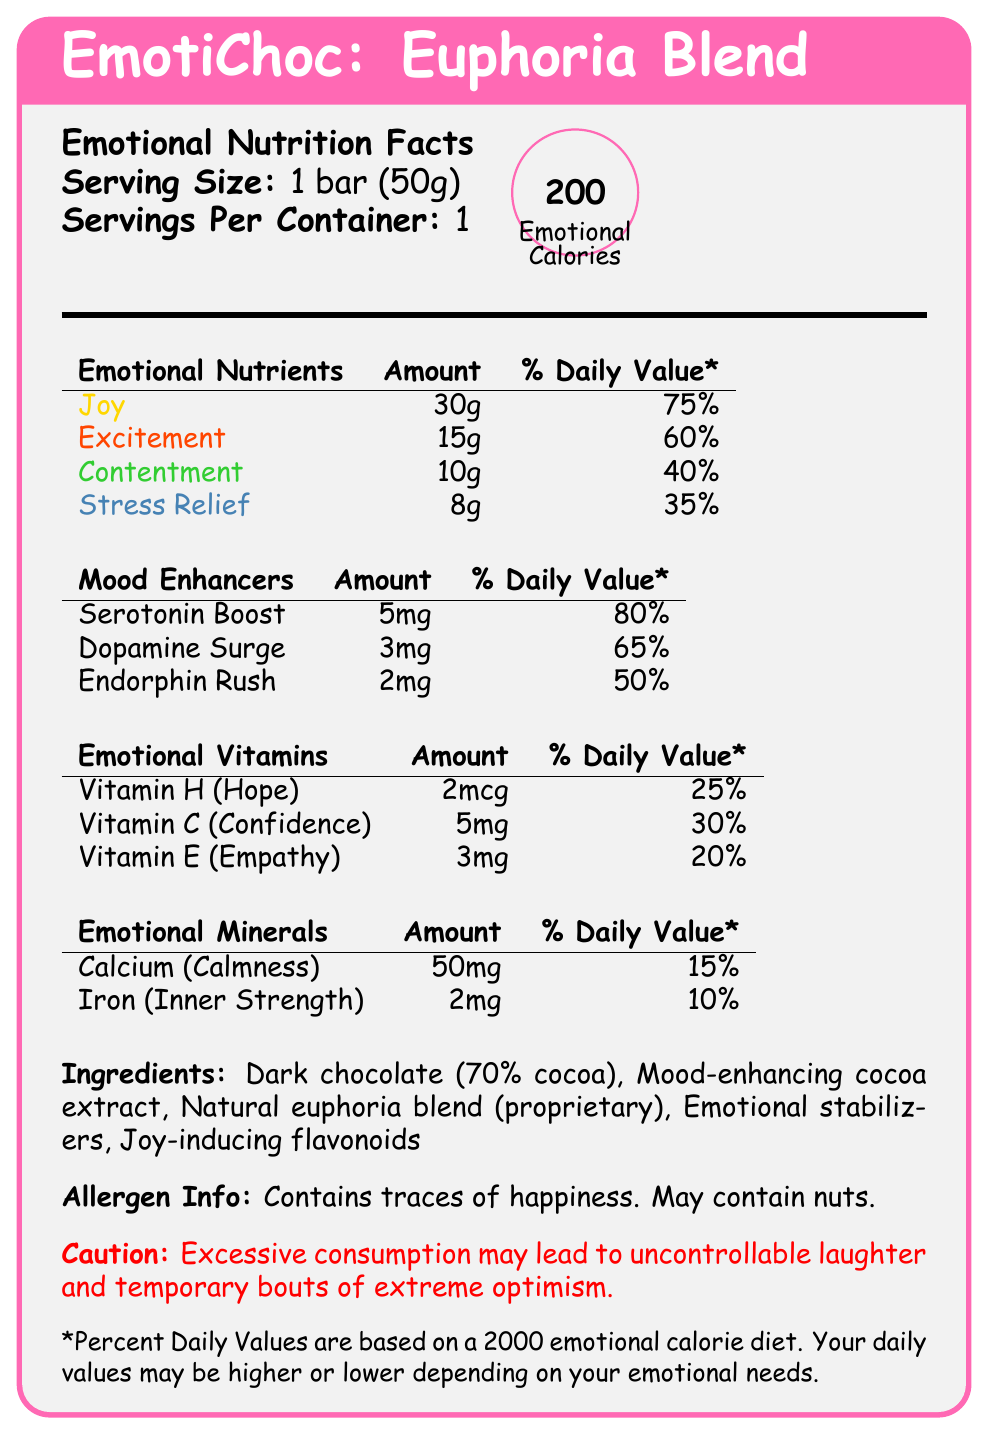What is the serving size for EmotiChoc: Euphoria Blend? The document mentions that the serving size is "1 bar (50g)".
Answer: 1 bar (50g) How many servings are there per container of the EmotiChoc: Euphoria Blend bar? The document states that there is 1 serving per container.
Answer: 1 How many emotional calories are in one serving of EmotiChoc: Euphoria Blend? The document specifies that each serving contains 200 emotional calories.
Answer: 200 What is the percentage of daily value for Joy in one bar of EmotiChoc: Euphoria Blend? The document lists Joy as having 30g, which is 75% of the daily value.
Answer: 75% Which emotional nutrient is the least present in the EmotiChoc: Euphoria Blend bar? The document states that Stress Relief has 8g, which is the least among the emotional nutrients listed.
Answer: Stress Relief Which mood enhancer has the highest daily value percentage in the EmotiChoc: Euphoria Blend bar? A. Serotonin Boost B. Dopamine Surge C. Endorphin Rush The document shows Serotonin Boost with an 80% daily value, which is higher than Dopamine Surge (65%) and Endorphin Rush (50%).
Answer: A. Serotonin Boost What amount of Vitamin H (Hope) does one bar of EmotiChoc: Euphoria Blend contain? The document includes Vitamin H (Hope) as 2mcg in one bar.
Answer: 2mcg Which of the following is not listed as an ingredient in EmotiChoc: Euphoria Blend? A. Dark chocolate B. Joy-inducing flavonoids C. Mood-balancing herbal extract D. Natural euphoria blend The ingredients listed include Dark chocolate, Joy-inducing flavonoids, and Natural euphoria blend but not Mood-balancing herbal extract.
Answer: C. Mood-balancing herbal extract Does the EmotiChoc: Euphoria Blend contain any allergen information? The document states that it contains traces of happiness and may contain nuts.
Answer: Yes What does the caution note in the EmotiChoc: Euphoria Blend mention? The caution warning in the document states these potential effects of consuming too much of the product.
Answer: Excessive consumption may lead to uncontrollable laughter and temporary bouts of extreme optimism. Summarize the main idea of the EmotiChoc: Euphoria Blend document. The document outlines the emotional benefits and nutritional information of EmotiChoc: Euphoria Blend, a chocolate bar designed to alter moods through specific emotional nutrients and mood enhancers, highlighting ingredients, daily values, and precautionary details.
Answer: EmotiChoc: Euphoria Blend is a mood-altering chocolate bar that provides various emotional nutrients, vitamins, and mood enhancers with detailed emotional nutritional information. It includes specific amounts and daily values of components like Joy, Excitement, and Serotonin Boost. The product is made from ingredients that promote mood enhancement and includes a caution about potential side effects from excessive consumption. What is the daily value percentage of Iron (Inner Strength) in one bar of the product? The document indicates that Iron (Inner Strength) has a daily value of 10%.
Answer: 10% What is the percentage of daily value for Dopamine Surge in the EmotiChoc: Euphoria Blend bar? The document lists Dopamine Surge as having a 65% daily value in one bar.
Answer: 65% What does the document suggest adding on the label related to storytelling visuals? The director's notes mention using vibrant, swirling colors to represent the emotional journey.
Answer: Consider using vibrant, swirling colors on the label to represent the emotional journey. Which vitamin is labeled as providing Empathy in the EmotiChoc: Euphoria Blend? A. Vitamin H B. Vitamin C C. Vitamin E The document states that Vitamin E corresponds to Empathy.
Answer: C. Vitamin E What emotional benefit is associated with consuming more Calcium in EmotiChoc: Euphoria Blend? The document associates Calcium (50mg per bar) with Calmness.
Answer: Calmness What is the proprietary ingredient blend mentioned in the EmotiChoc: Euphoria Blend’s ingredient list? The document lists the proprietary ingredient blend as "Natural euphoria blend".
Answer: Natural euphoria blend What is the visual representation suggested for showcasing the ‘before and after’ effects of EmotiChoc? The director's notes suggest incorporating a QR code that links to a short film for this purpose.
Answer: Add a QR code linking to a short film showcasing the 'before and after' effects of EmotiChoc. How much Serotonin Boost does one bar of EmotiChoc: Euphoria Blend contain? The document states that one bar contains 5mg of Serotonin Boost.
Answer: 5mg What unique component is present in the EmotiChoc: Euphoria Blend but not in regular chocolate bars? The document provides detailed information on emotional nutrients, vitamins, and mood enhancers present in the EmotiChoc: Euphoria Blend, but does not offer a direct comparison to regular chocolate bars.
Answer: Cannot be determined 